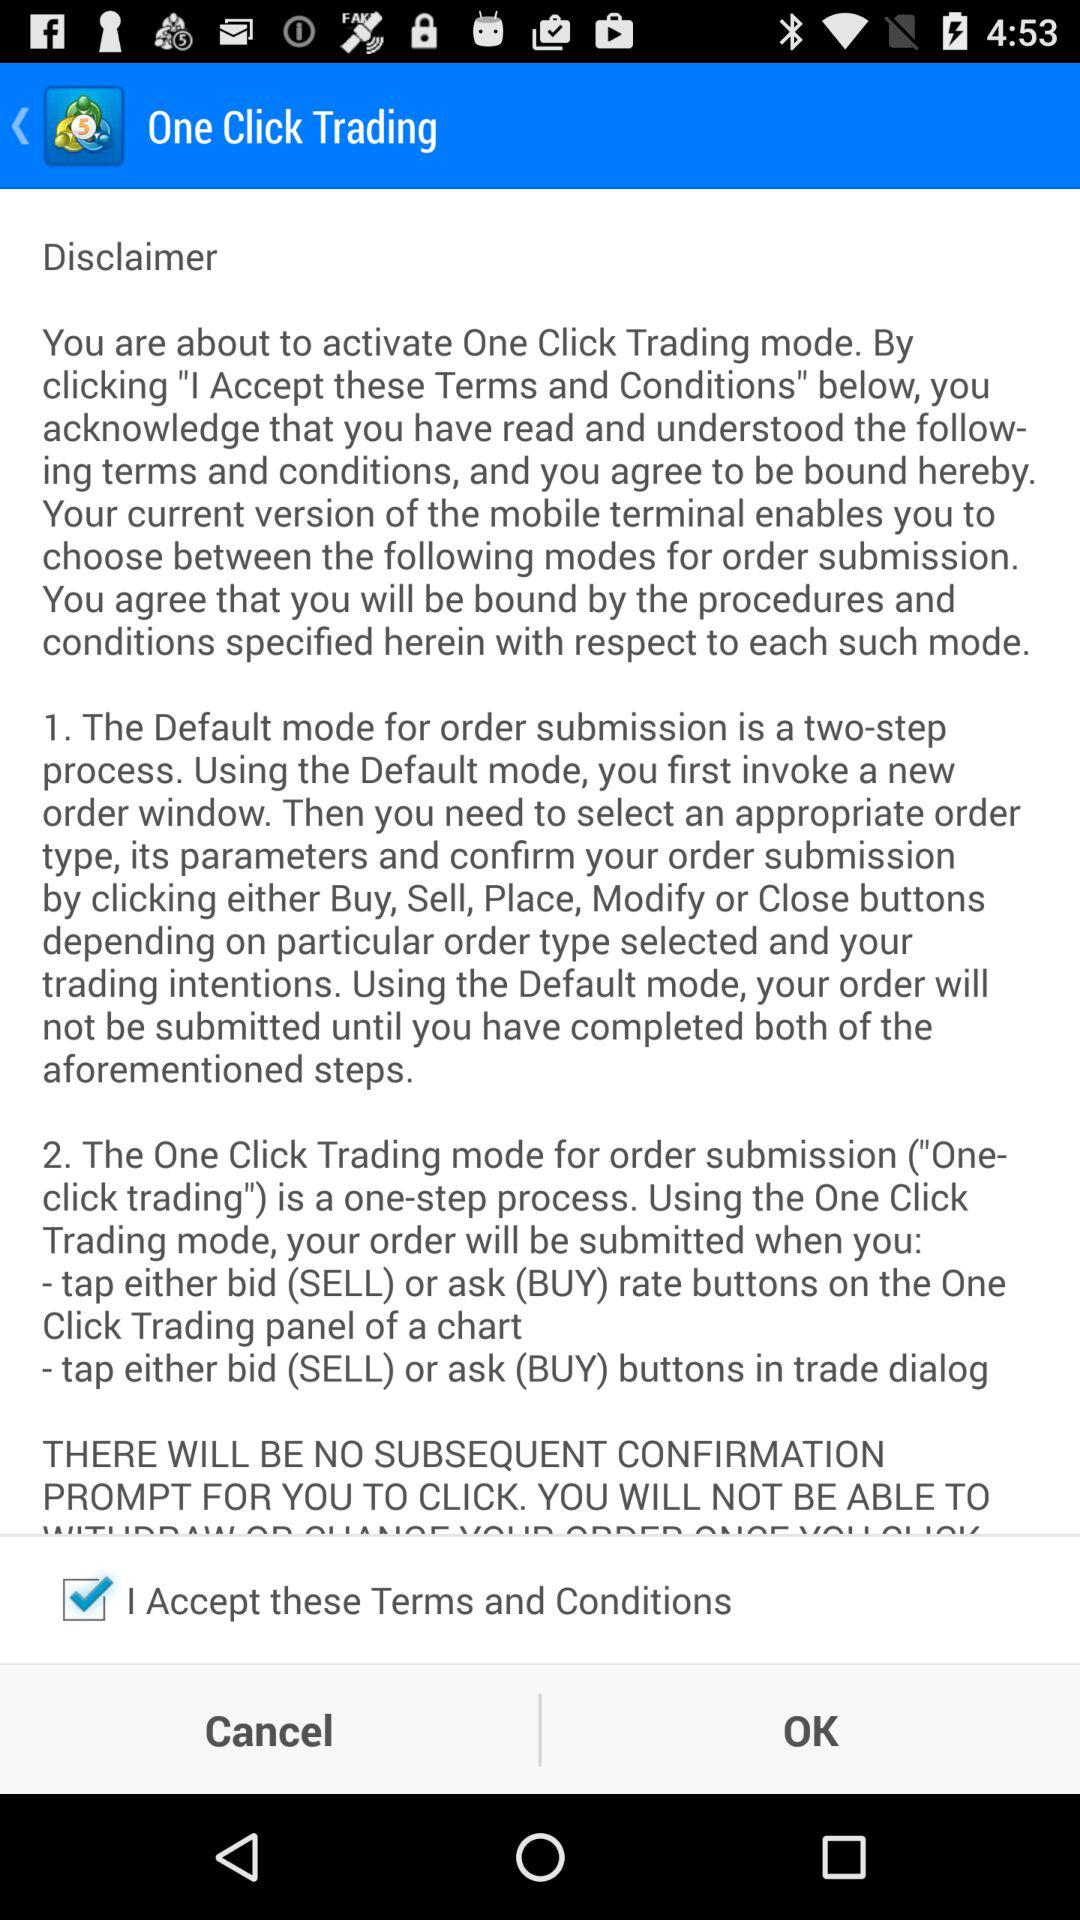How many steps are there in the default mode?
Answer the question using a single word or phrase. 2 